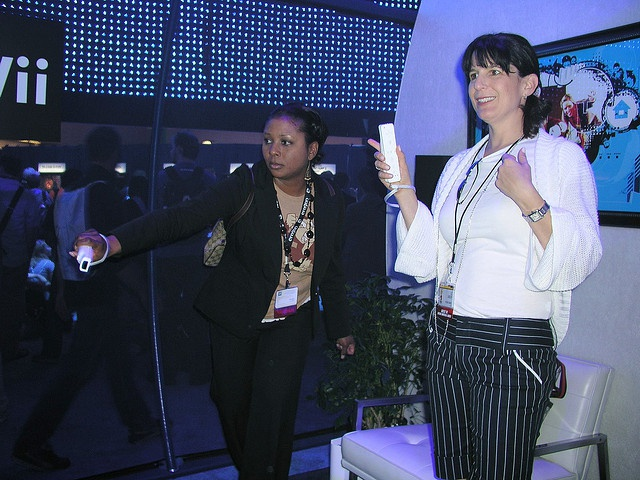Describe the objects in this image and their specific colors. I can see people in black, lavender, and darkgray tones, people in black, gray, and navy tones, people in black, navy, and darkblue tones, chair in black, darkgray, violet, and gray tones, and people in black, navy, darkblue, and blue tones in this image. 